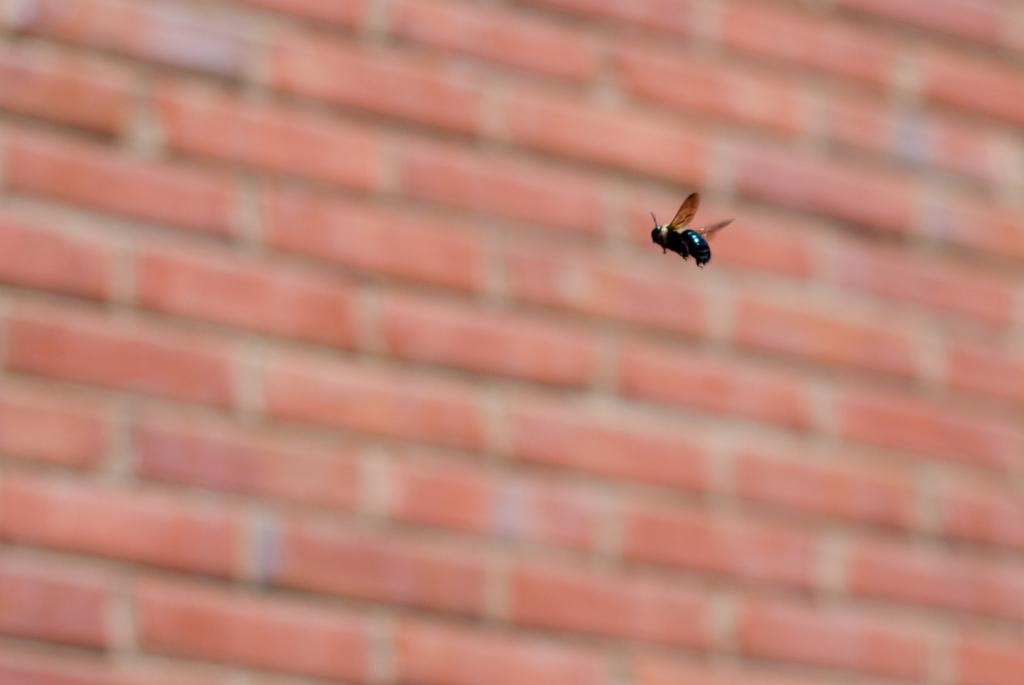What is the main subject of the image? There is an insect in the center of the image. Can you describe the appearance of the insect? The insect is black and brown in color. What can be seen in the background of the image? There is a blurry wall in the background of the image. What type of wool is being combed in the image? There is no wool or comb present in the image; it features an insect in the center. 